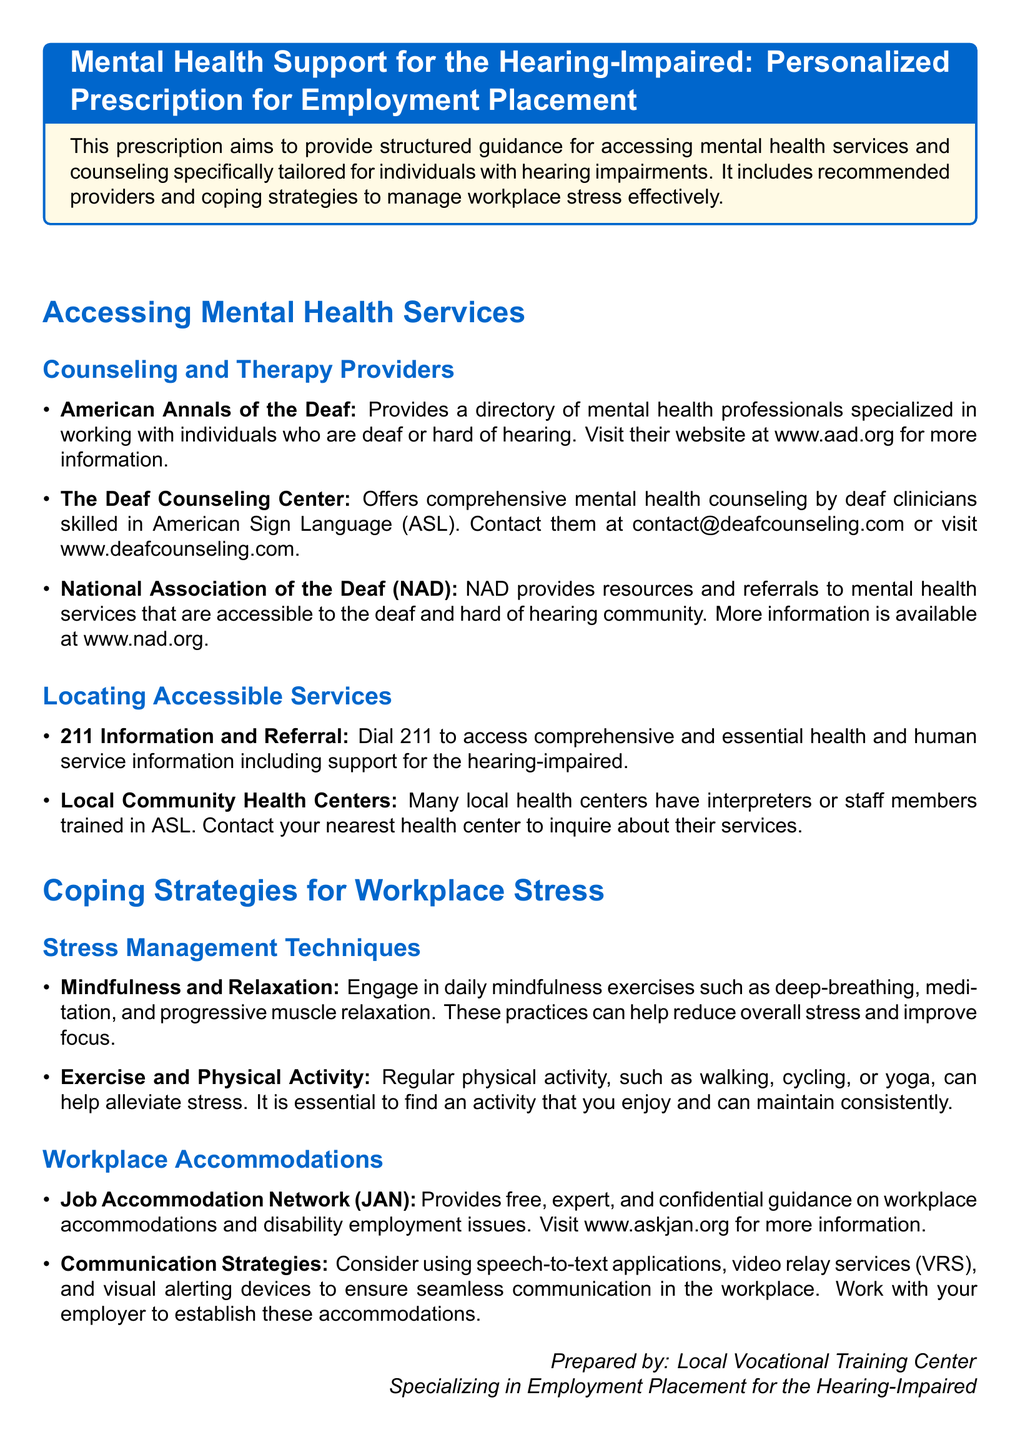What is the title of the document? The title is the main heading of the document that summarizes its content.
Answer: Mental Health Support for the Hearing-Impaired: Personalized Prescription for Employment Placement What does the American Annals of the Deaf provide? This refers to the service or information offered by the organization mentioned in the document regarding mental health.
Answer: A directory of mental health professionals specialized in working with individuals who are deaf or hard of hearing How can you contact The Deaf Counseling Center? This requires identifying the contact method mentioned for the specific service.
Answer: contact@deafcounseling.com What is the phone number to access 211 Information and Referral? This question seeks a specific contact number provided in the document.
Answer: 211 Which organization offers guidance on workplace accommodations? This identifies the specific resource that gives advice on managing work environments for the hearing-impaired.
Answer: Job Accommodation Network (JAN) Name one stress management technique mentioned in the document. This asks for a specific example of a coping strategy listed in the document.
Answer: Mindfulness and Relaxation What service does the National Association of the Deaf provide? This refers to the type of resources or support offered by the NAD as mentioned.
Answer: Resources and referrals to mental health services What should you do if you need interpreters at local health centers? This question looks for actionable information regarding services at health centers.
Answer: Inquire about their services What type of document is this? This identifies the purpose and format of the document based on its structure and content.
Answer: Prescription 